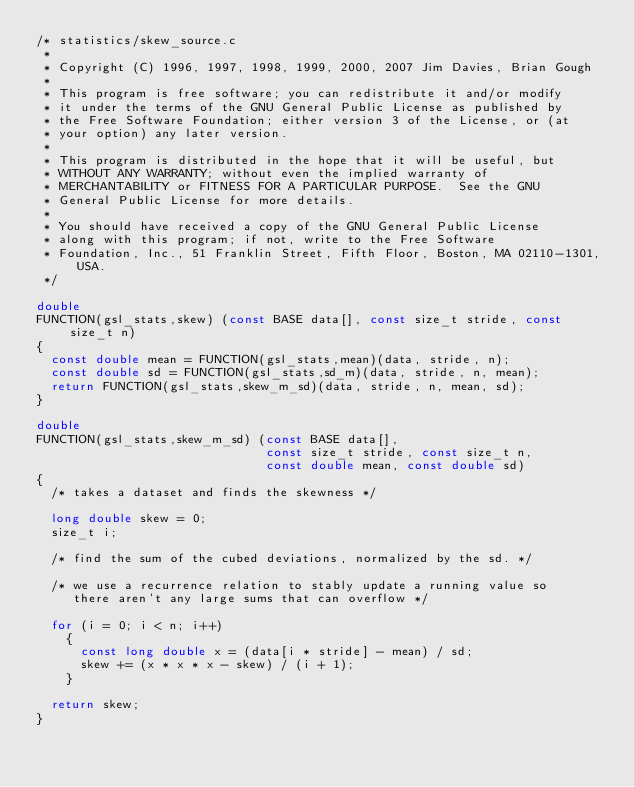<code> <loc_0><loc_0><loc_500><loc_500><_C_>/* statistics/skew_source.c
 * 
 * Copyright (C) 1996, 1997, 1998, 1999, 2000, 2007 Jim Davies, Brian Gough
 * 
 * This program is free software; you can redistribute it and/or modify
 * it under the terms of the GNU General Public License as published by
 * the Free Software Foundation; either version 3 of the License, or (at
 * your option) any later version.
 * 
 * This program is distributed in the hope that it will be useful, but
 * WITHOUT ANY WARRANTY; without even the implied warranty of
 * MERCHANTABILITY or FITNESS FOR A PARTICULAR PURPOSE.  See the GNU
 * General Public License for more details.
 * 
 * You should have received a copy of the GNU General Public License
 * along with this program; if not, write to the Free Software
 * Foundation, Inc., 51 Franklin Street, Fifth Floor, Boston, MA 02110-1301, USA.
 */

double 
FUNCTION(gsl_stats,skew) (const BASE data[], const size_t stride, const size_t n)
{
  const double mean = FUNCTION(gsl_stats,mean)(data, stride, n);
  const double sd = FUNCTION(gsl_stats,sd_m)(data, stride, n, mean);
  return FUNCTION(gsl_stats,skew_m_sd)(data, stride, n, mean, sd);
}
    
double 
FUNCTION(gsl_stats,skew_m_sd) (const BASE data[], 
                               const size_t stride, const size_t n,
                               const double mean, const double sd)
{
  /* takes a dataset and finds the skewness */

  long double skew = 0;
  size_t i;

  /* find the sum of the cubed deviations, normalized by the sd. */

  /* we use a recurrence relation to stably update a running value so
     there aren't any large sums that can overflow */

  for (i = 0; i < n; i++)
    {
      const long double x = (data[i * stride] - mean) / sd;
      skew += (x * x * x - skew) / (i + 1);
    }

  return skew;
}

</code> 